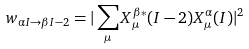<formula> <loc_0><loc_0><loc_500><loc_500>w _ { \alpha I \rightarrow \beta I - 2 } = | \sum _ { \mu } X ^ { \beta * } _ { \mu } ( I - 2 ) X ^ { \alpha } _ { \mu } ( I ) | ^ { 2 }</formula> 